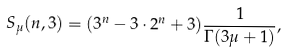Convert formula to latex. <formula><loc_0><loc_0><loc_500><loc_500>S _ { \mu } ( n , 3 ) = ( 3 ^ { n } - 3 \cdot 2 ^ { n } + 3 ) \frac { 1 } { \Gamma ( 3 \mu + 1 ) } ,</formula> 